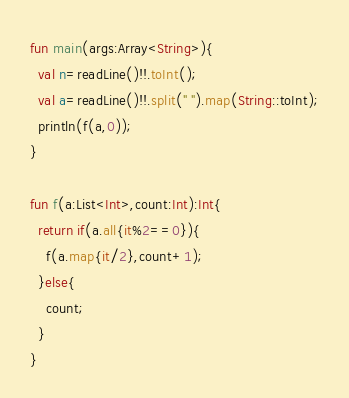Convert code to text. <code><loc_0><loc_0><loc_500><loc_500><_Kotlin_>fun main(args:Array<String>){
  val n=readLine()!!.toInt();
  val a=readLine()!!.split(" ").map(String::toInt);
  println(f(a,0));
}

fun f(a:List<Int>,count:Int):Int{
  return if(a.all{it%2==0}){
    f(a.map{it/2},count+1);
  }else{
    count;
  }
}</code> 